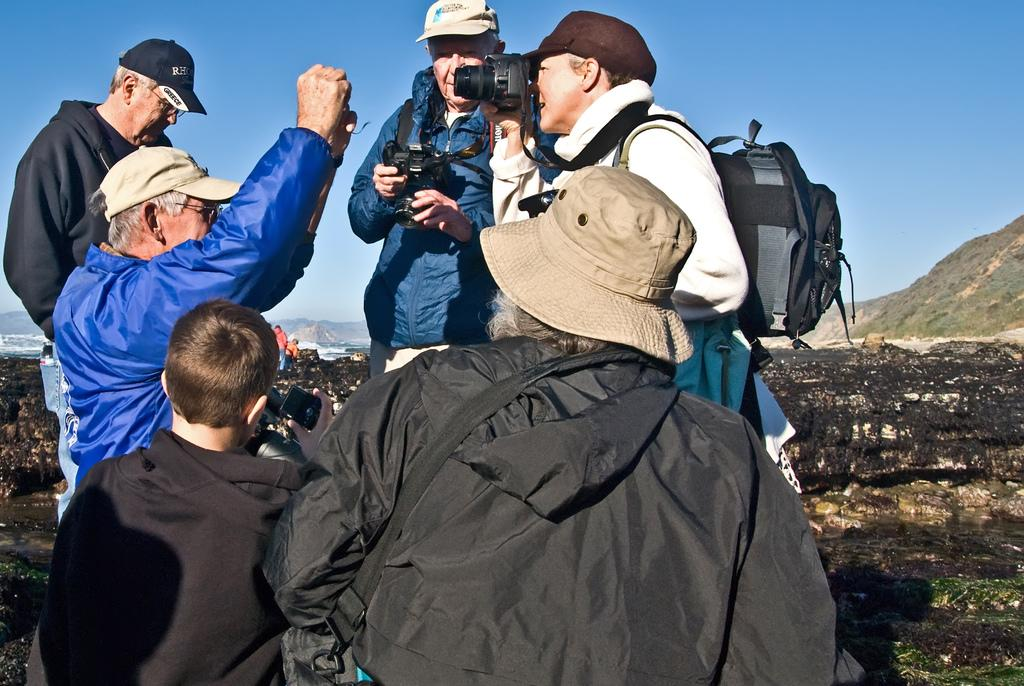How many people are present in the image? There are six persons standing in the image. Can you describe the woman on the right side of the image? The woman is on the right side of the image, and she is holding a camera. What is the woman doing with the camera? The woman is clicking an image with the camera. Where is the nest of the sheep located in the image? There are no sheep or nests present in the image. What is the process of creating the image being captured by the woman? The provided facts do not give information about the process of creating the image being captured by the woman. 